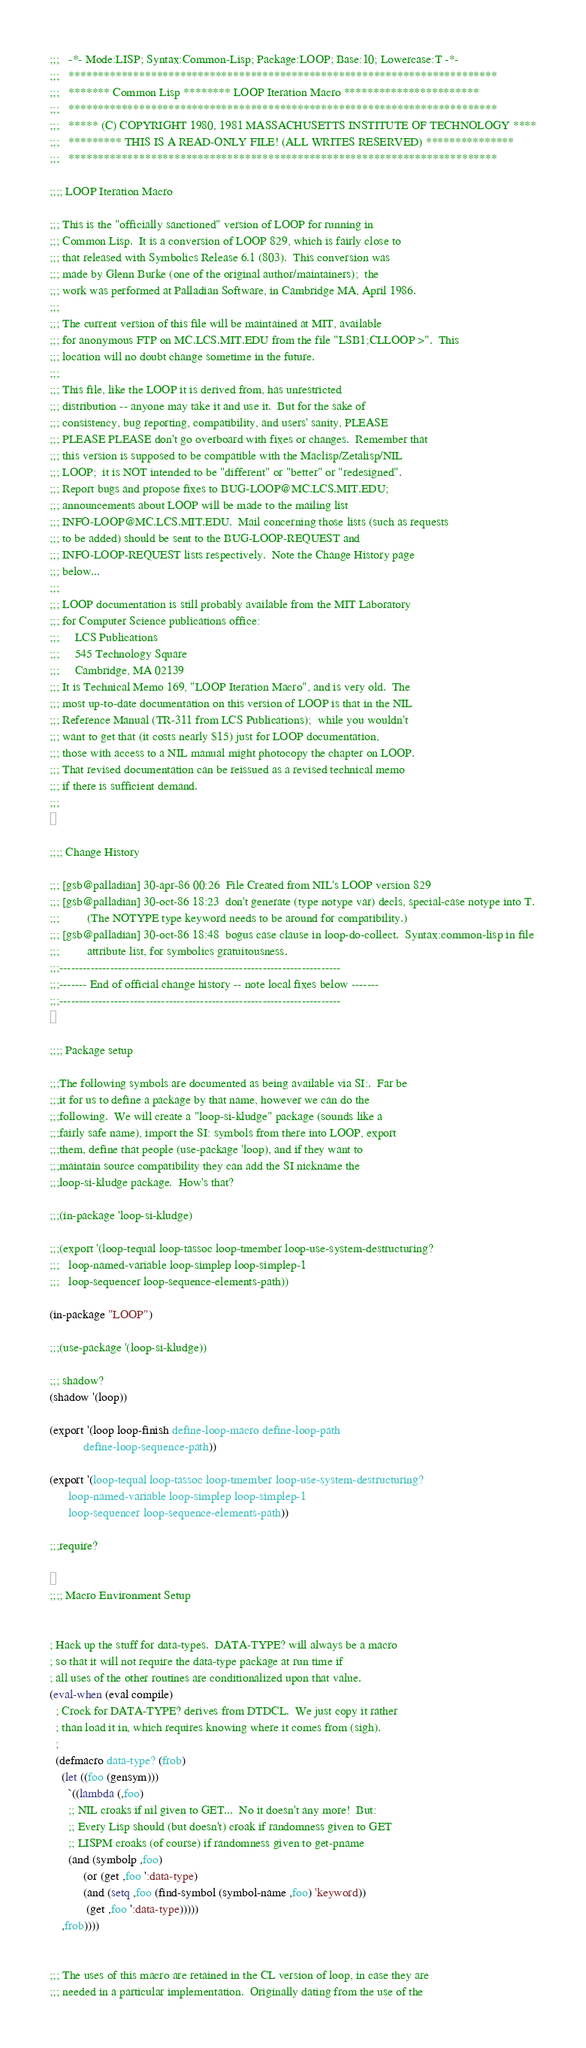<code> <loc_0><loc_0><loc_500><loc_500><_Lisp_>;;;   -*- Mode:LISP; Syntax:Common-Lisp; Package:LOOP; Base:10; Lowercase:T -*-
;;;   *************************************************************************
;;;   ******* Common Lisp ******** LOOP Iteration Macro ***********************
;;;   *************************************************************************
;;;   ***** (C) COPYRIGHT 1980, 1981 MASSACHUSETTS INSTITUTE OF TECHNOLOGY ****
;;;   ********* THIS IS A READ-ONLY FILE! (ALL WRITES RESERVED) ***************
;;;   *************************************************************************

;;;; LOOP Iteration Macro

;;; This is the "officially sanctioned" version of LOOP for running in
;;; Common Lisp.  It is a conversion of LOOP 829, which is fairly close to
;;; that released with Symbolics Release 6.1 (803).  This conversion was
;;; made by Glenn Burke (one of the original author/maintainers);  the
;;; work was performed at Palladian Software, in Cambridge MA, April 1986.
;;; 
;;; The current version of this file will be maintained at MIT, available
;;; for anonymous FTP on MC.LCS.MIT.EDU from the file "LSB1;CLLOOP >".  This
;;; location will no doubt change sometime in the future.
;;; 
;;; This file, like the LOOP it is derived from, has unrestricted
;;; distribution -- anyone may take it and use it.  But for the sake of
;;; consistency, bug reporting, compatibility, and users' sanity, PLEASE
;;; PLEASE PLEASE don't go overboard with fixes or changes.  Remember that
;;; this version is supposed to be compatible with the Maclisp/Zetalisp/NIL
;;; LOOP;  it is NOT intended to be "different" or "better" or "redesigned".
;;; Report bugs and propose fixes to BUG-LOOP@MC.LCS.MIT.EDU;
;;; announcements about LOOP will be made to the mailing list
;;; INFO-LOOP@MC.LCS.MIT.EDU.  Mail concerning those lists (such as requests
;;; to be added) should be sent to the BUG-LOOP-REQUEST and
;;; INFO-LOOP-REQUEST lists respectively.  Note the Change History page
;;; below...
;;; 
;;; LOOP documentation is still probably available from the MIT Laboratory
;;; for Computer Science publications office:
;;; 	LCS Publications
;;; 	545 Technology Square
;;; 	Cambridge, MA 02139
;;; It is Technical Memo 169, "LOOP Iteration Macro", and is very old.  The
;;; most up-to-date documentation on this version of LOOP is that in the NIL
;;; Reference Manual (TR-311 from LCS Publications);  while you wouldn't
;;; want to get that (it costs nearly $15) just for LOOP documentation,
;;; those with access to a NIL manual might photocopy the chapter on LOOP.
;;; That revised documentation can be reissued as a revised technical memo
;;; if there is sufficient demand.
;;;


;;;; Change History

;;; [gsb@palladian] 30-apr-86 00:26  File Created from NIL's LOOP version 829
;;; [gsb@palladian] 30-oct-86 18:23  don't generate (type notype var) decls, special-case notype into T.
;;;		    (The NOTYPE type keyword needs to be around for compatibility.)
;;; [gsb@palladian] 30-oct-86 18:48  bogus case clause in loop-do-collect.  Syntax:common-lisp in file
;;;		    attribute list, for symbolics gratuitousness.
;;;------------------------------------------------------------------------
;;;------- End of official change history -- note local fixes below -------
;;;------------------------------------------------------------------------


;;;; Package setup

;;;The following symbols are documented as being available via SI:.  Far be
;;;it for us to define a package by that name, however we can do the
;;;following.  We will create a "loop-si-kludge" package (sounds like a
;;;fairly safe name), import the SI: symbols from there into LOOP, export
;;;them, define that people (use-package 'loop), and if they want to
;;;maintain source compatibility they can add the SI nickname the
;;;loop-si-kludge package.  How's that?

;;;(in-package 'loop-si-kludge)

;;;(export '(loop-tequal loop-tassoc loop-tmember loop-use-system-destructuring?
;;;	  loop-named-variable loop-simplep loop-simplep-1
;;;	  loop-sequencer loop-sequence-elements-path))

(in-package "LOOP")

;;;(use-package '(loop-si-kludge))

;;; shadow?
(shadow '(loop))

(export '(loop loop-finish define-loop-macro define-loop-path
	       define-loop-sequence-path))

(export '(loop-tequal loop-tassoc loop-tmember loop-use-system-destructuring?
	  loop-named-variable loop-simplep loop-simplep-1
	  loop-sequencer loop-sequence-elements-path))

;;;require?


;;;; Macro Environment Setup


; Hack up the stuff for data-types.  DATA-TYPE? will always be a macro
; so that it will not require the data-type package at run time if
; all uses of the other routines are conditionalized upon that value.
(eval-when (eval compile)
  ; Crock for DATA-TYPE? derives from DTDCL.  We just copy it rather
  ; than load it in, which requires knowing where it comes from (sigh).
  ; 
  (defmacro data-type? (frob)
    (let ((foo (gensym)))
      `((lambda (,foo)
	  ;; NIL croaks if nil given to GET...  No it doesn't any more!  But:
	  ;; Every Lisp should (but doesn't) croak if randomness given to GET
	  ;; LISPM croaks (of course) if randomness given to get-pname
	  (and (symbolp ,foo)
	       (or (get ,foo ':data-type)
		   (and (setq ,foo (find-symbol (symbol-name ,foo) 'keyword))
			(get ,foo ':data-type)))))
	,frob))))


;;; The uses of this macro are retained in the CL version of loop, in case they are
;;; needed in a particular implementation.  Originally dating from the use of the</code> 